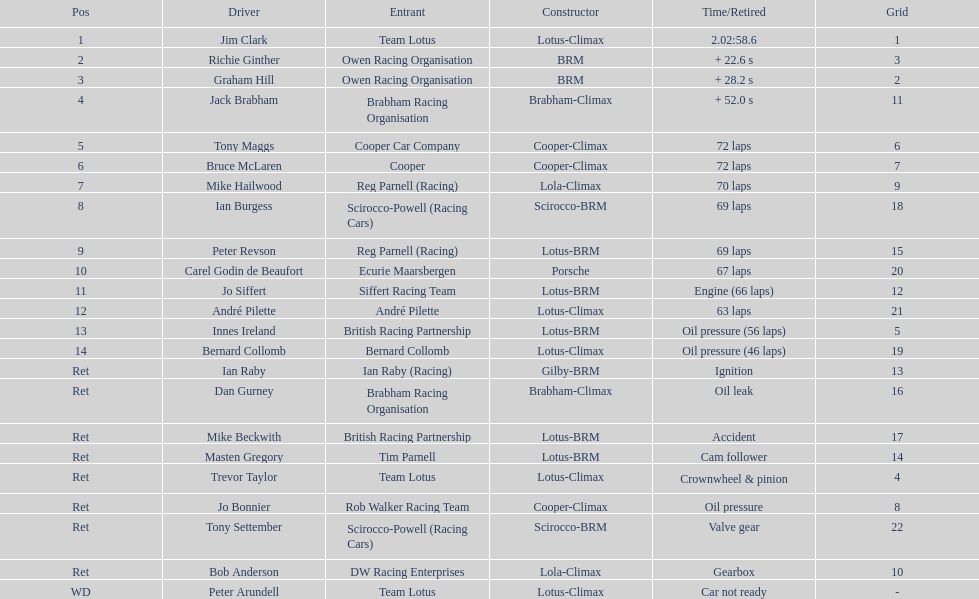How many different drivers are listed? 23. 